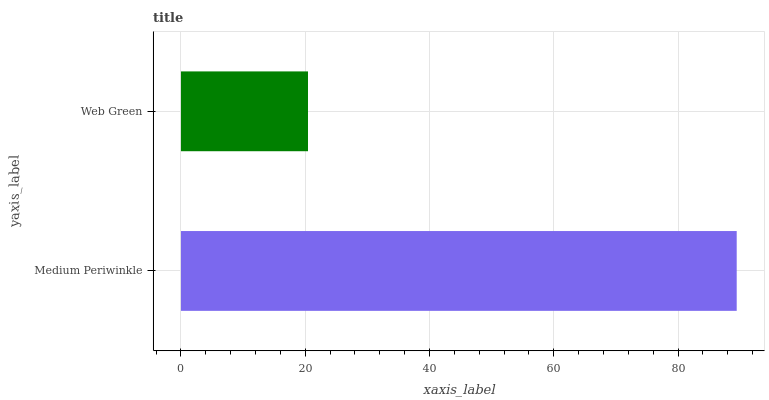Is Web Green the minimum?
Answer yes or no. Yes. Is Medium Periwinkle the maximum?
Answer yes or no. Yes. Is Web Green the maximum?
Answer yes or no. No. Is Medium Periwinkle greater than Web Green?
Answer yes or no. Yes. Is Web Green less than Medium Periwinkle?
Answer yes or no. Yes. Is Web Green greater than Medium Periwinkle?
Answer yes or no. No. Is Medium Periwinkle less than Web Green?
Answer yes or no. No. Is Medium Periwinkle the high median?
Answer yes or no. Yes. Is Web Green the low median?
Answer yes or no. Yes. Is Web Green the high median?
Answer yes or no. No. Is Medium Periwinkle the low median?
Answer yes or no. No. 